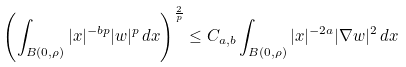<formula> <loc_0><loc_0><loc_500><loc_500>\left ( \int _ { B ( 0 , \rho ) } | x | ^ { - b p } | w | ^ { p } \, d x \right ) ^ { \frac { 2 } { p } } \leq C _ { a , b } \int _ { B ( 0 , \rho ) } | x | ^ { - 2 a } | \nabla w | ^ { 2 } \, d x</formula> 